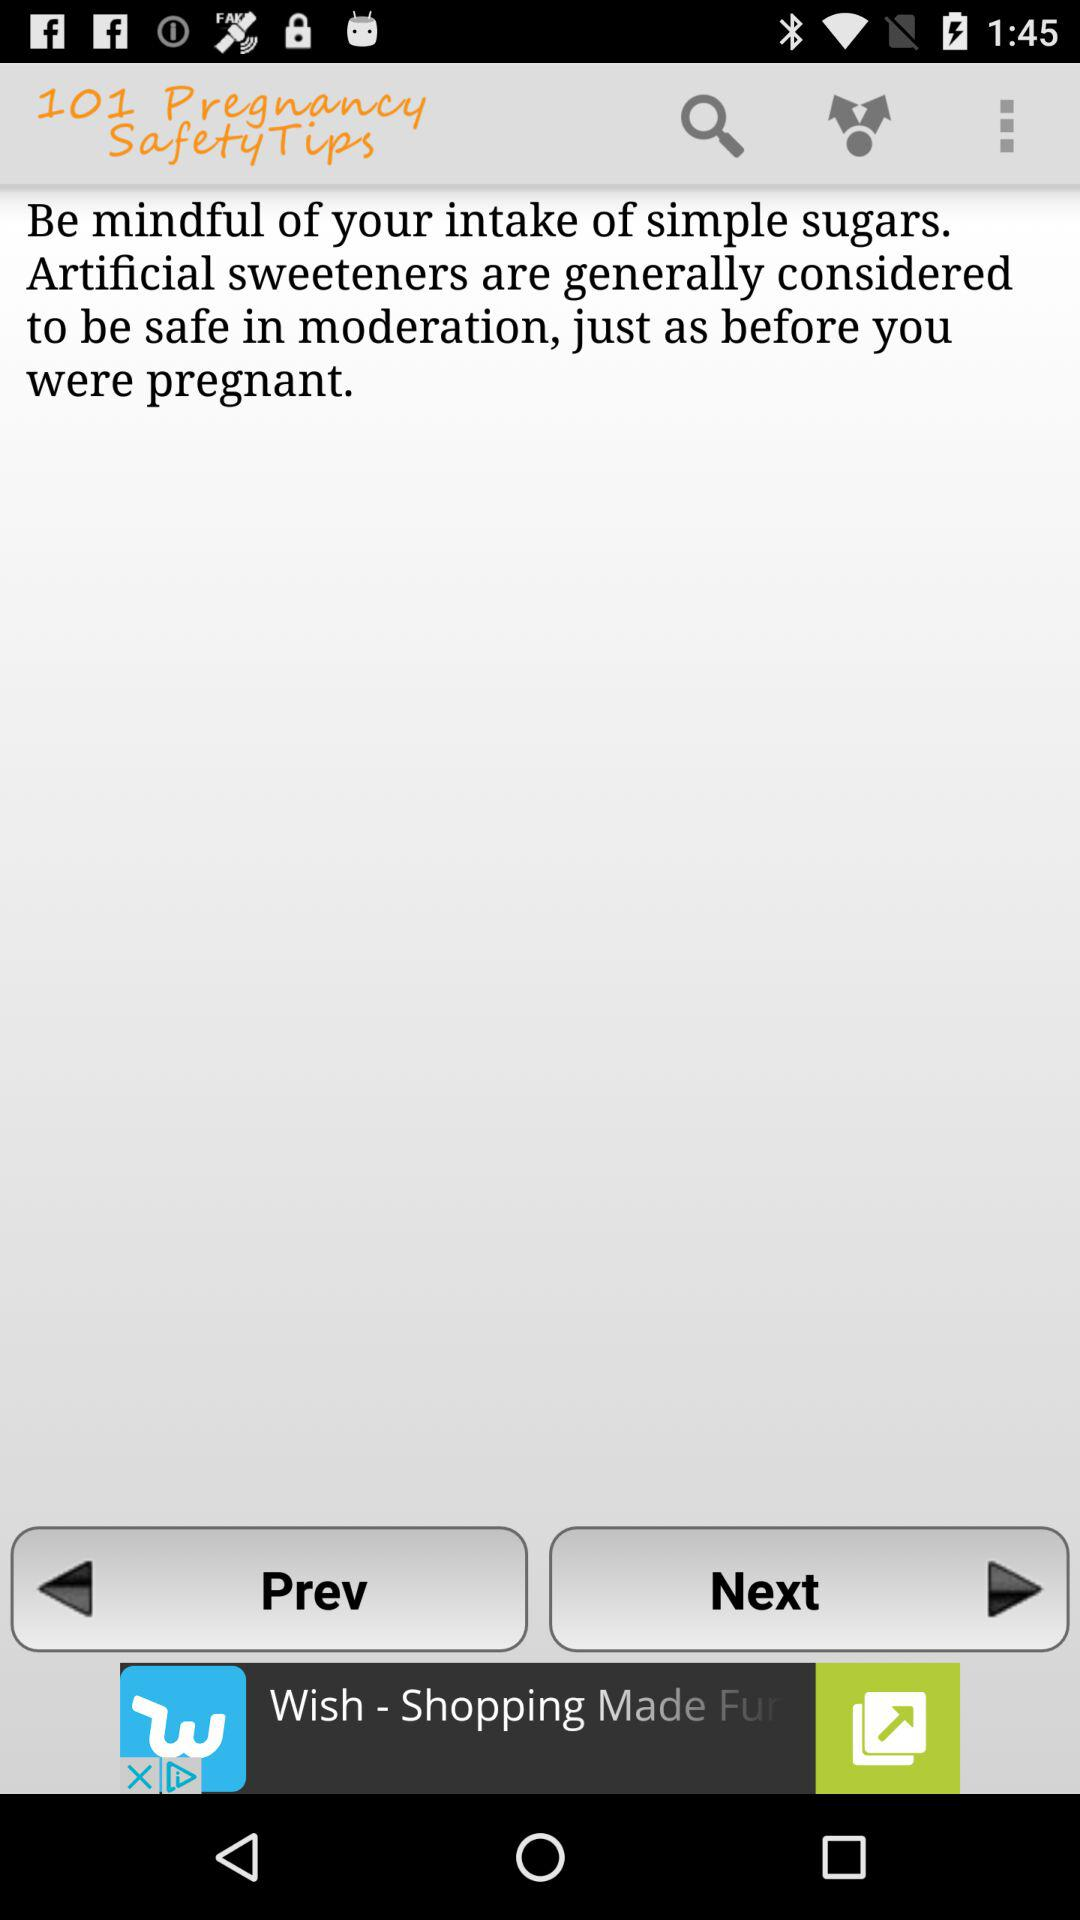How many pregnancy safety tips are there?
When the provided information is insufficient, respond with <no answer>. <no answer> 